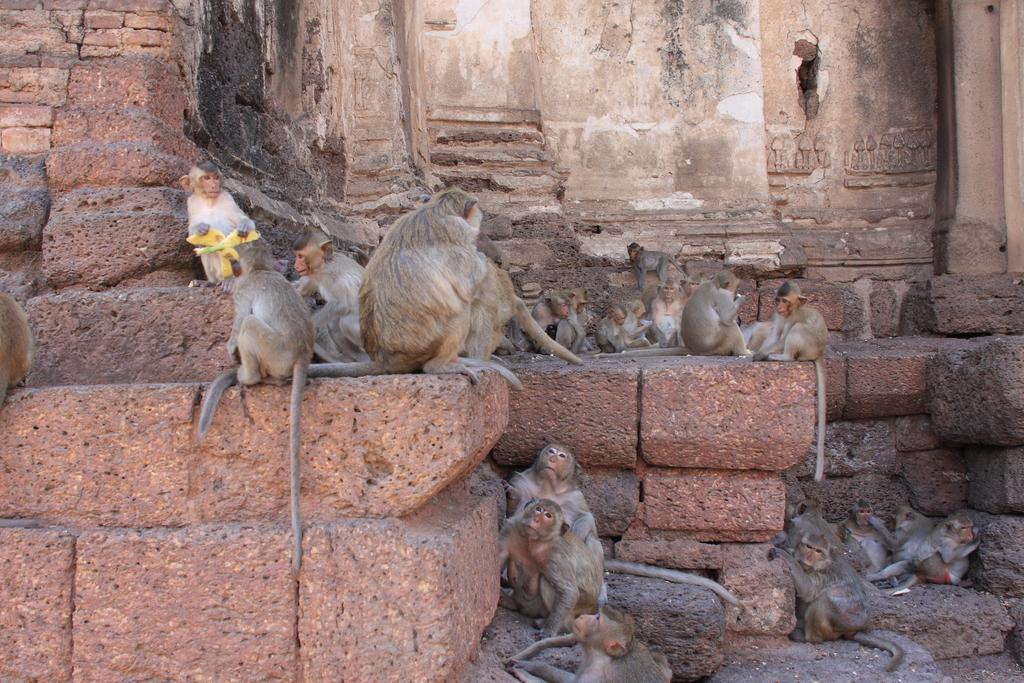Describe this image in one or two sentences. A group of monkeys are sitting on this stone wall. 